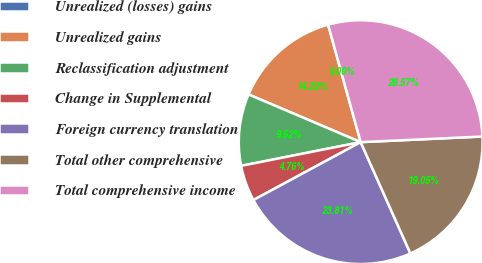Convert chart to OTSL. <chart><loc_0><loc_0><loc_500><loc_500><pie_chart><fcel>Unrealized (losses) gains<fcel>Unrealized gains<fcel>Reclassification adjustment<fcel>Change in Supplemental<fcel>Foreign currency translation<fcel>Total other comprehensive<fcel>Total comprehensive income<nl><fcel>0.0%<fcel>14.29%<fcel>9.52%<fcel>4.76%<fcel>23.81%<fcel>19.05%<fcel>28.57%<nl></chart> 